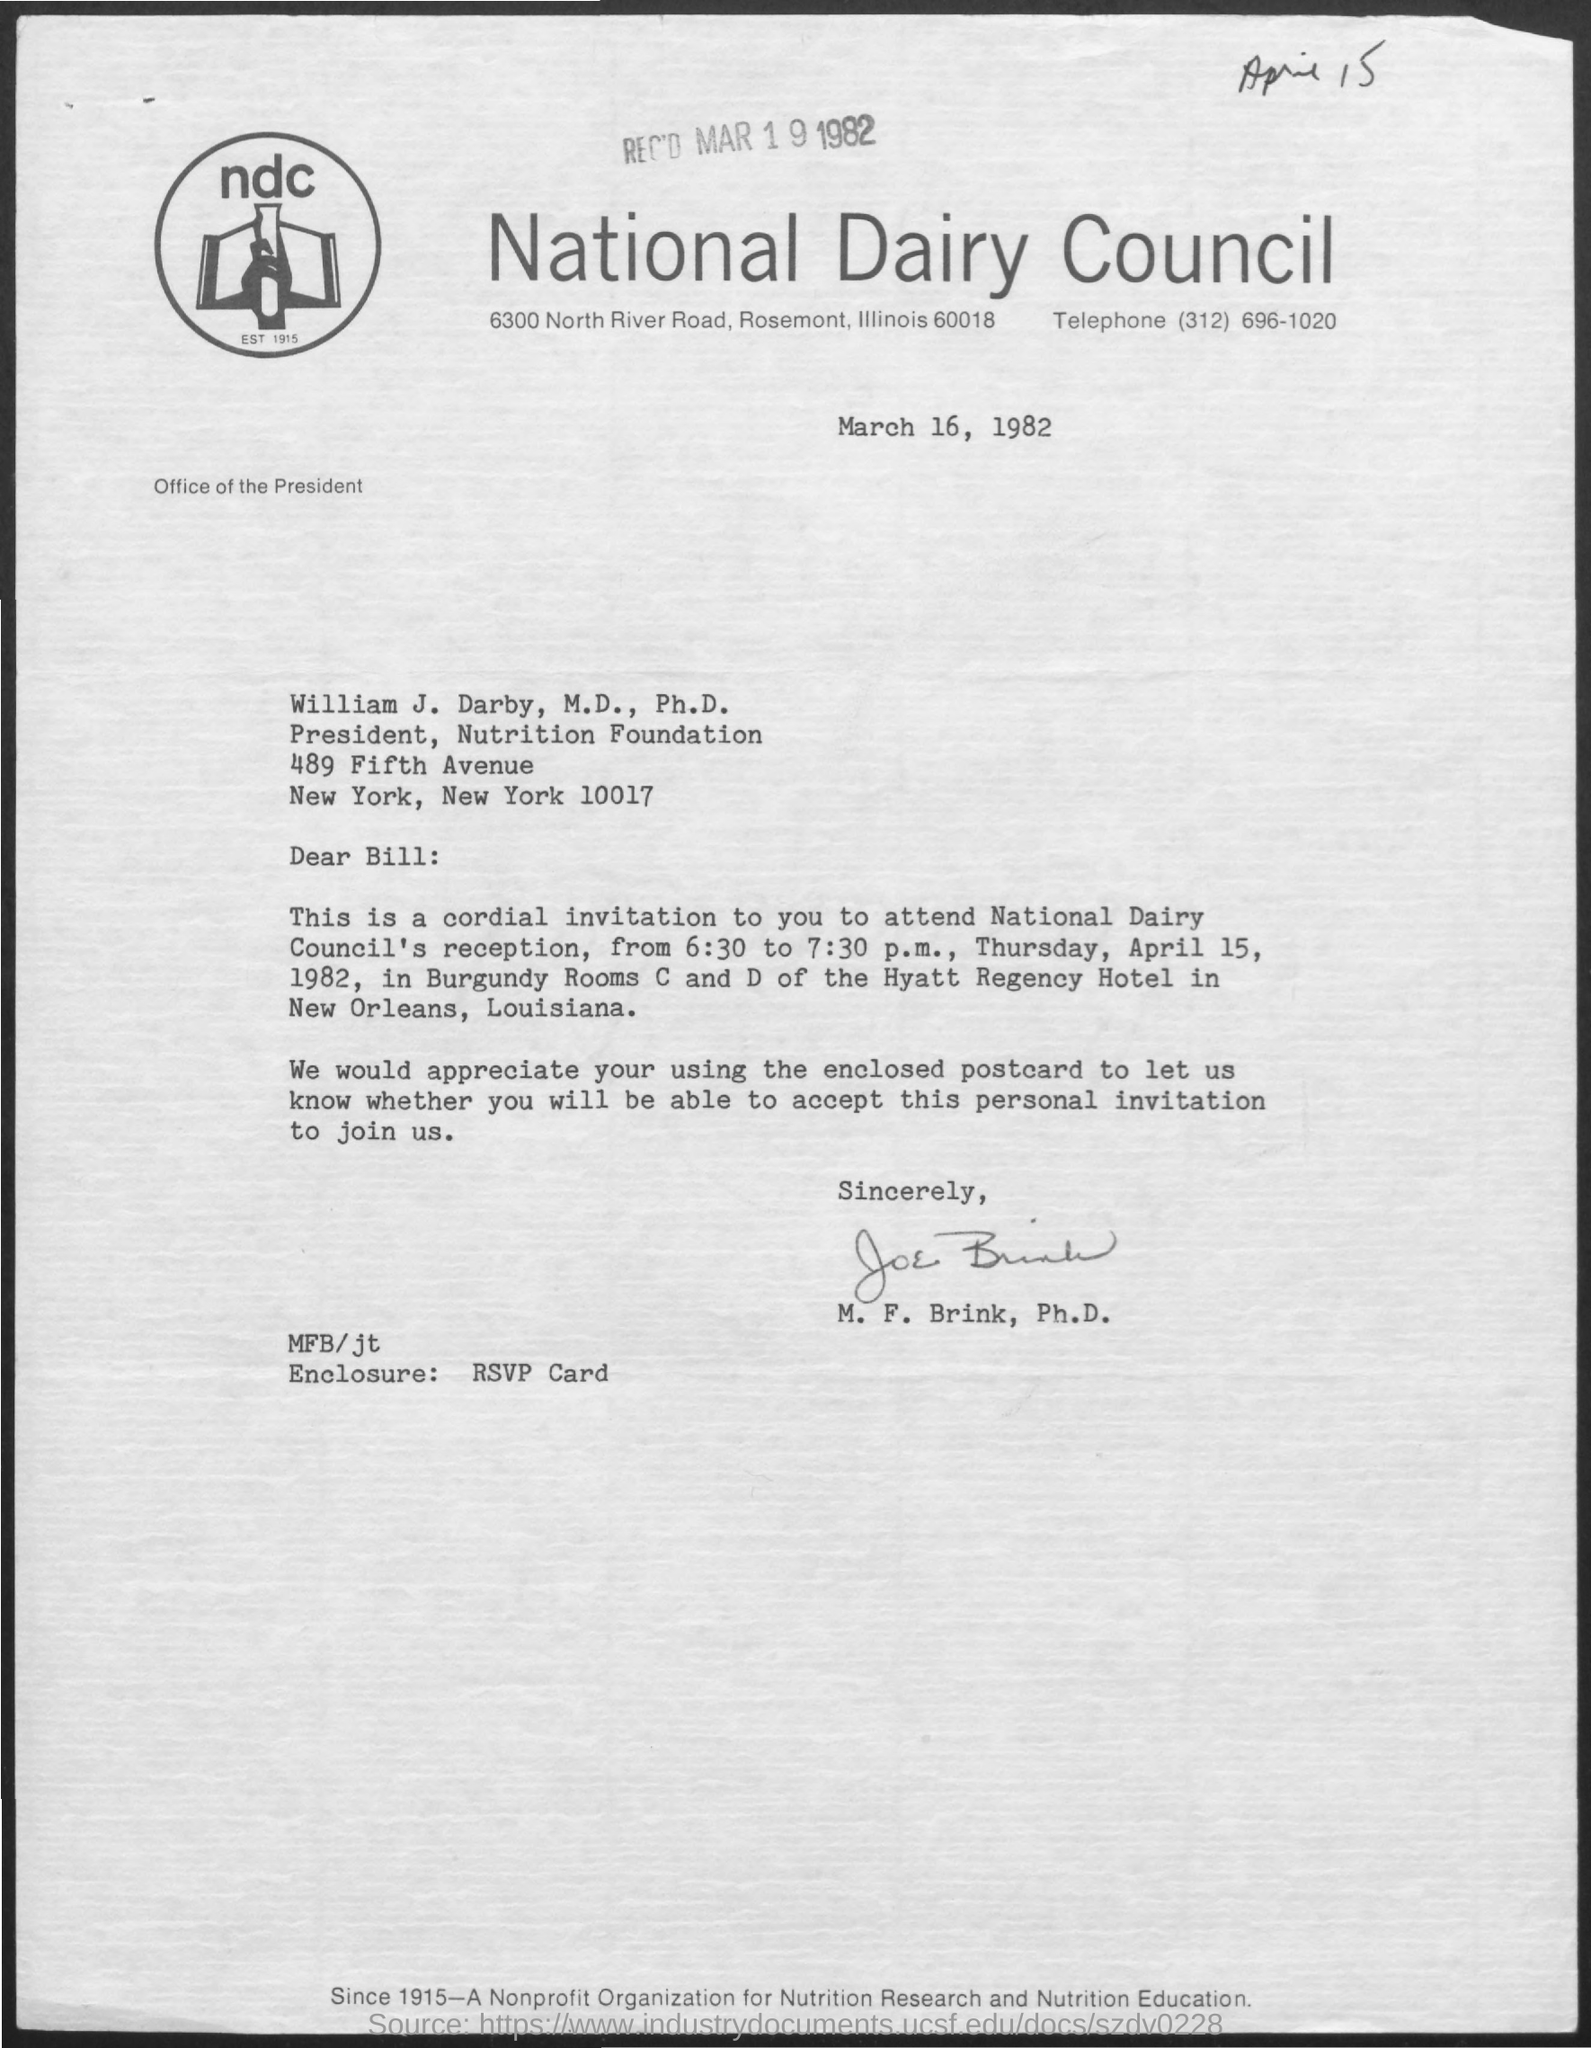Which organizations letterhead is this?
Offer a very short reply. National Dairy Council. When is the document dated?
Give a very brief answer. March 16, 1982. When was the letter received?
Make the answer very short. Mar 19 1982. What is the telephone number given?
Offer a terse response. (312) 696-1020. Who is the sender?
Offer a terse response. M. F. Brink, Ph.D. What is the enclosure?
Your answer should be very brief. RSVP Card. On which date is the National Dairy Council's Reception?
Offer a terse response. Thursday, April 15, 1982. 